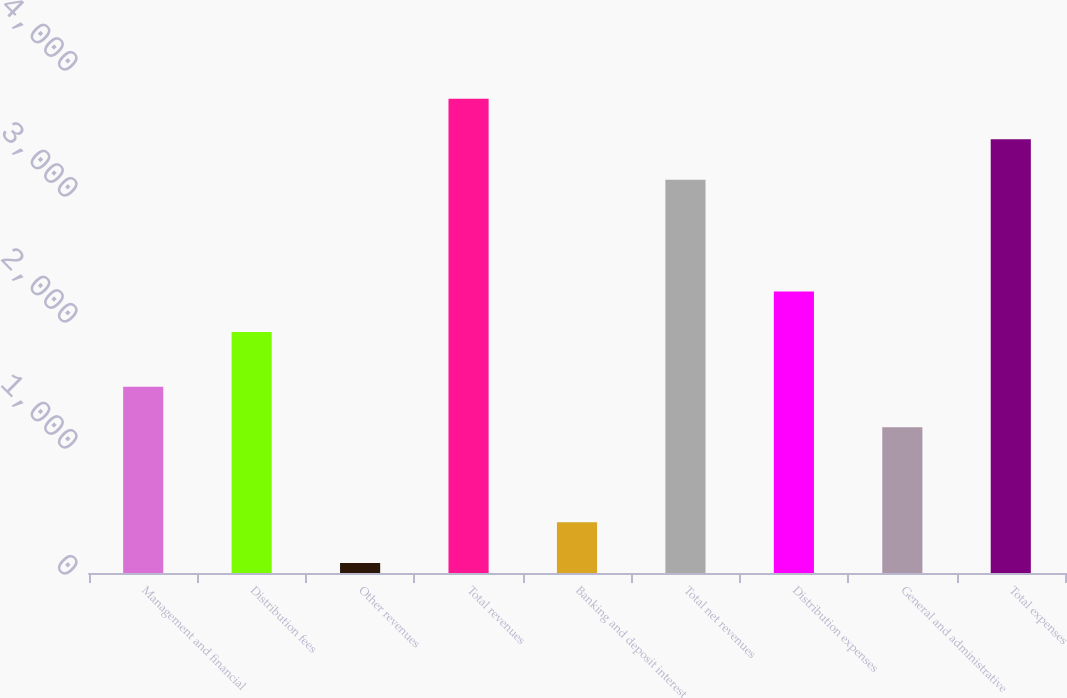<chart> <loc_0><loc_0><loc_500><loc_500><bar_chart><fcel>Management and financial<fcel>Distribution fees<fcel>Other revenues<fcel>Total revenues<fcel>Banking and deposit interest<fcel>Total net revenues<fcel>Distribution expenses<fcel>General and administrative<fcel>Total expenses<nl><fcel>1477.9<fcel>1912<fcel>80<fcel>3764.8<fcel>401.9<fcel>3121<fcel>2233.9<fcel>1156<fcel>3442.9<nl></chart> 